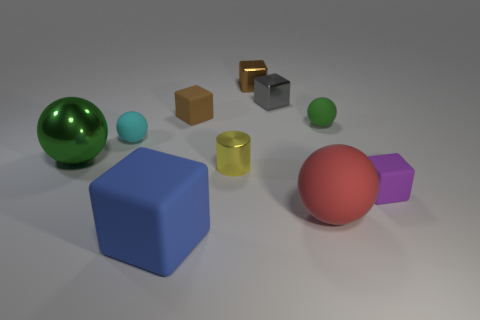How many objects are both on the left side of the purple block and on the right side of the tiny gray metallic block?
Offer a terse response. 2. How many other tiny yellow objects have the same material as the yellow thing?
Offer a very short reply. 0. What is the color of the big sphere that is the same material as the large blue thing?
Offer a very short reply. Red. Is the number of tiny cyan matte balls less than the number of blue spheres?
Keep it short and to the point. No. What is the material of the object to the right of the green thing that is right of the green sphere left of the red object?
Your answer should be compact. Rubber. What is the material of the tiny yellow thing?
Your answer should be very brief. Metal. There is a tiny cube that is in front of the yellow cylinder; is its color the same as the big ball that is right of the blue rubber thing?
Keep it short and to the point. No. Is the number of yellow things greater than the number of tiny spheres?
Your response must be concise. No. What number of other balls have the same color as the large metallic sphere?
Provide a succinct answer. 1. What color is the big matte thing that is the same shape as the small purple object?
Your answer should be very brief. Blue. 